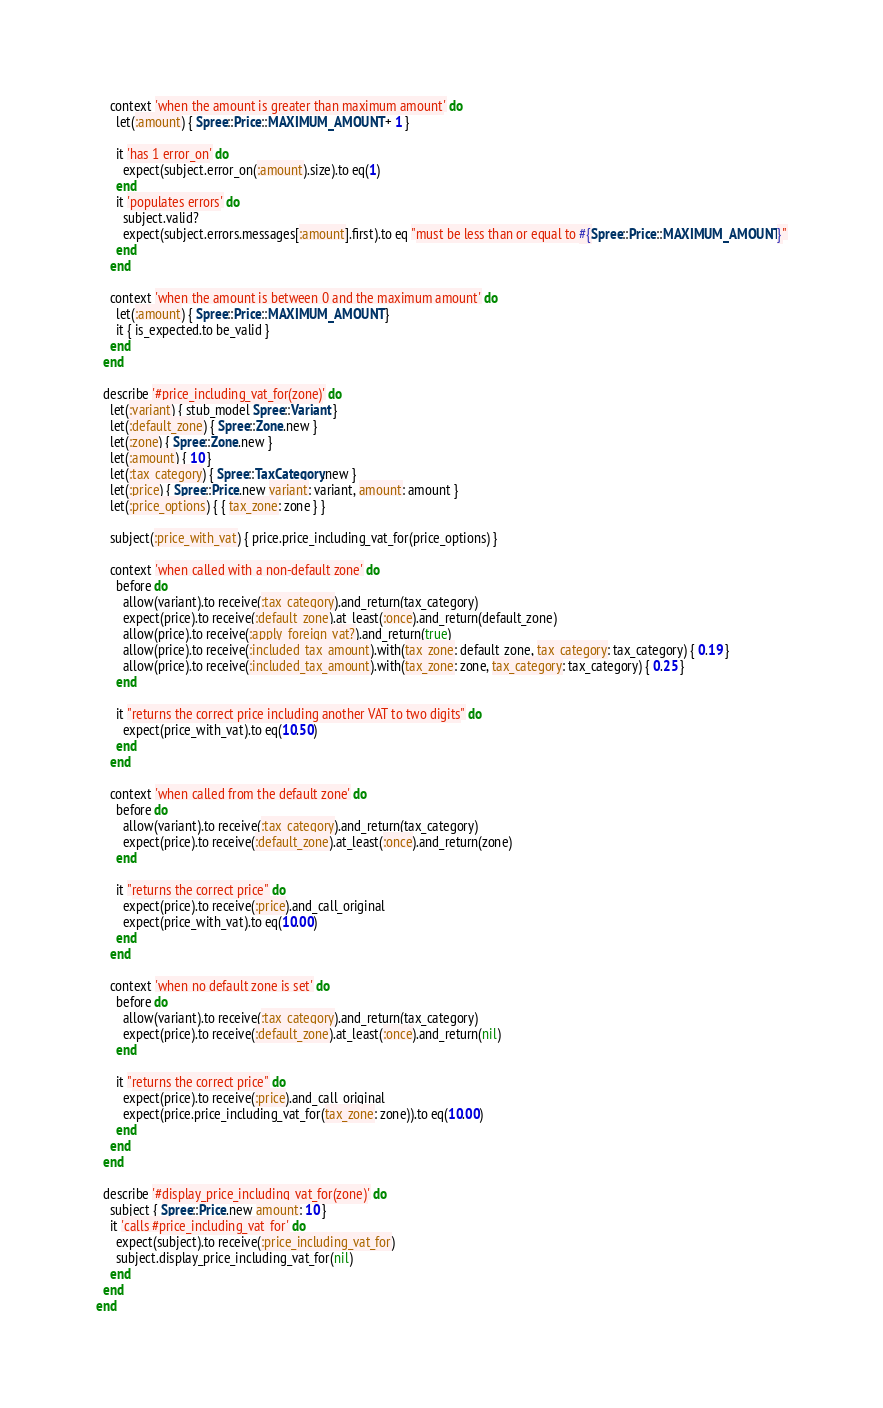Convert code to text. <code><loc_0><loc_0><loc_500><loc_500><_Ruby_>    context 'when the amount is greater than maximum amount' do
      let(:amount) { Spree::Price::MAXIMUM_AMOUNT + 1 }

      it 'has 1 error_on' do
        expect(subject.error_on(:amount).size).to eq(1)
      end
      it 'populates errors' do
        subject.valid?
        expect(subject.errors.messages[:amount].first).to eq "must be less than or equal to #{Spree::Price::MAXIMUM_AMOUNT}"
      end
    end

    context 'when the amount is between 0 and the maximum amount' do
      let(:amount) { Spree::Price::MAXIMUM_AMOUNT }
      it { is_expected.to be_valid }
    end
  end

  describe '#price_including_vat_for(zone)' do
    let(:variant) { stub_model Spree::Variant }
    let(:default_zone) { Spree::Zone.new }
    let(:zone) { Spree::Zone.new }
    let(:amount) { 10 }
    let(:tax_category) { Spree::TaxCategory.new }
    let(:price) { Spree::Price.new variant: variant, amount: amount }
    let(:price_options) { { tax_zone: zone } }

    subject(:price_with_vat) { price.price_including_vat_for(price_options) }

    context 'when called with a non-default zone' do
      before do
        allow(variant).to receive(:tax_category).and_return(tax_category)
        expect(price).to receive(:default_zone).at_least(:once).and_return(default_zone)
        allow(price).to receive(:apply_foreign_vat?).and_return(true)
        allow(price).to receive(:included_tax_amount).with(tax_zone: default_zone, tax_category: tax_category) { 0.19 }
        allow(price).to receive(:included_tax_amount).with(tax_zone: zone, tax_category: tax_category) { 0.25 }
      end

      it "returns the correct price including another VAT to two digits" do
        expect(price_with_vat).to eq(10.50)
      end
    end

    context 'when called from the default zone' do
      before do
        allow(variant).to receive(:tax_category).and_return(tax_category)
        expect(price).to receive(:default_zone).at_least(:once).and_return(zone)
      end

      it "returns the correct price" do
        expect(price).to receive(:price).and_call_original
        expect(price_with_vat).to eq(10.00)
      end
    end

    context 'when no default zone is set' do
      before do
        allow(variant).to receive(:tax_category).and_return(tax_category)
        expect(price).to receive(:default_zone).at_least(:once).and_return(nil)
      end

      it "returns the correct price" do
        expect(price).to receive(:price).and_call_original
        expect(price.price_including_vat_for(tax_zone: zone)).to eq(10.00)
      end
    end
  end

  describe '#display_price_including_vat_for(zone)' do
    subject { Spree::Price.new amount: 10 }
    it 'calls #price_including_vat_for' do
      expect(subject).to receive(:price_including_vat_for)
      subject.display_price_including_vat_for(nil)
    end
  end
end
</code> 